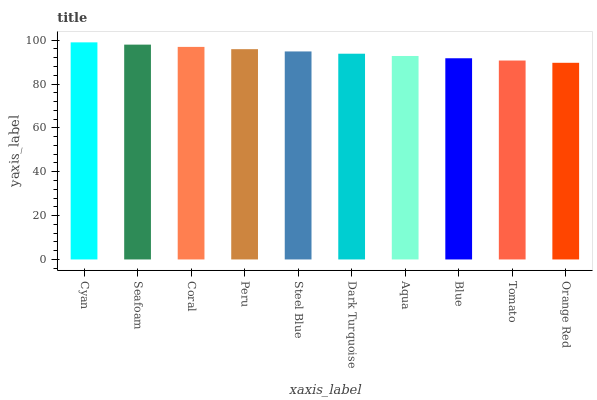Is Orange Red the minimum?
Answer yes or no. Yes. Is Cyan the maximum?
Answer yes or no. Yes. Is Seafoam the minimum?
Answer yes or no. No. Is Seafoam the maximum?
Answer yes or no. No. Is Cyan greater than Seafoam?
Answer yes or no. Yes. Is Seafoam less than Cyan?
Answer yes or no. Yes. Is Seafoam greater than Cyan?
Answer yes or no. No. Is Cyan less than Seafoam?
Answer yes or no. No. Is Steel Blue the high median?
Answer yes or no. Yes. Is Dark Turquoise the low median?
Answer yes or no. Yes. Is Dark Turquoise the high median?
Answer yes or no. No. Is Peru the low median?
Answer yes or no. No. 